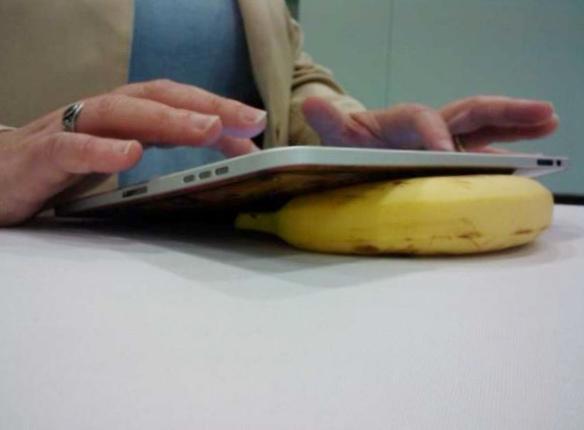How many boats are to the right of the stop sign?
Give a very brief answer. 0. 